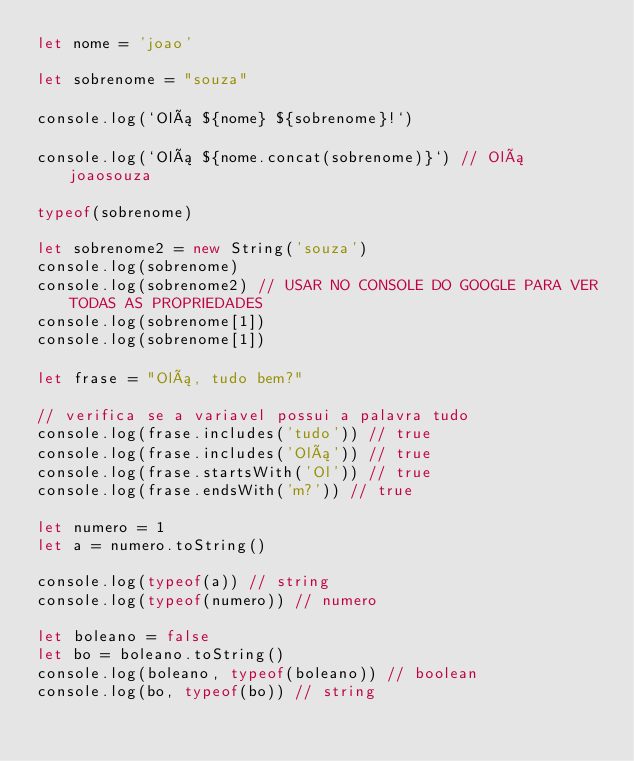Convert code to text. <code><loc_0><loc_0><loc_500><loc_500><_JavaScript_>let nome = 'joao'

let sobrenome = "souza"

console.log(`Olá ${nome} ${sobrenome}!`)

console.log(`Olá ${nome.concat(sobrenome)}`) // Olá joaosouza

typeof(sobrenome)

let sobrenome2 = new String('souza')
console.log(sobrenome)
console.log(sobrenome2) // USAR NO CONSOLE DO GOOGLE PARA VER TODAS AS PROPRIEDADES
console.log(sobrenome[1])
console.log(sobrenome[1])

let frase = "Olá, tudo bem?"

// verifica se a variavel possui a palavra tudo
console.log(frase.includes('tudo')) // true
console.log(frase.includes('Olá')) // true
console.log(frase.startsWith('Ol')) // true
console.log(frase.endsWith('m?')) // true

let numero = 1
let a = numero.toString()

console.log(typeof(a)) // string
console.log(typeof(numero)) // numero

let boleano = false
let bo = boleano.toString()
console.log(boleano, typeof(boleano)) // boolean
console.log(bo, typeof(bo)) // string
</code> 